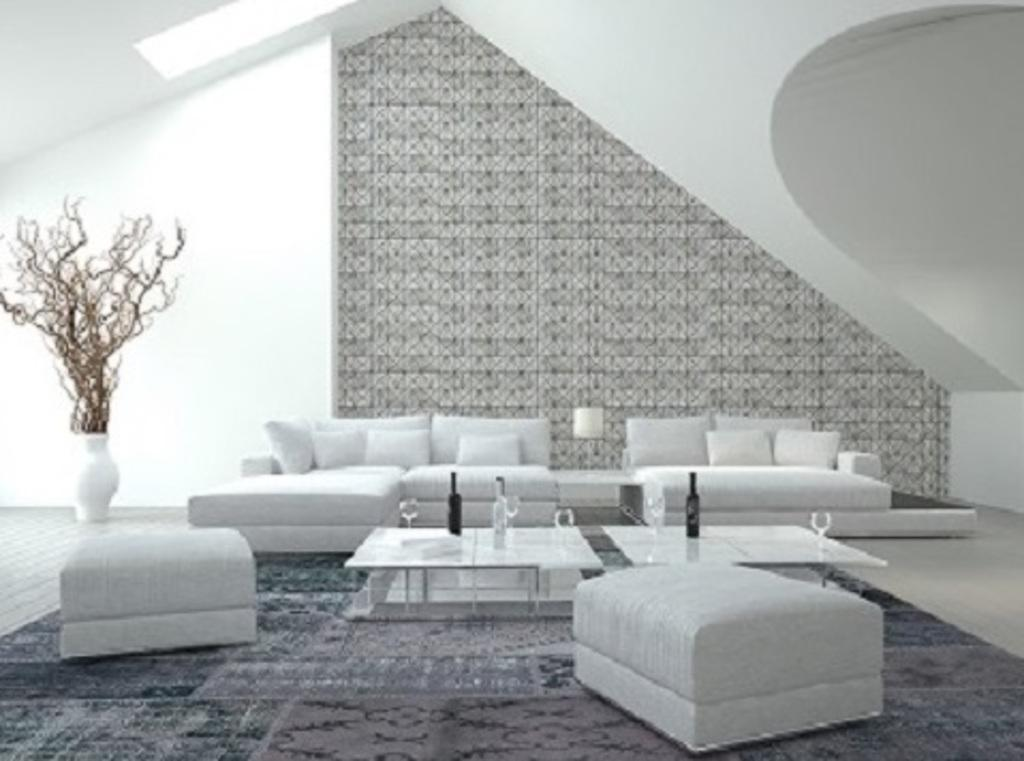What type of furniture is in the image? There is a sofa set in the image. How many tables are in front of the sofa set? There are 2 tables in front of the sofa set. What items can be seen on the tables? There are 3 bottles and 4 glasses on the tables. What can be seen in the background of the image? There is a wall, a lamp, and a plant in a pot in the background of the image. What type of journey is depicted in the image? There is no journey depicted in the image; it features a sofa set, tables, bottles, glasses, a wall, a lamp, and a plant in a pot. How many ducks are visible in the image? There are no ducks present in the image. 